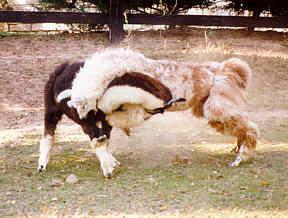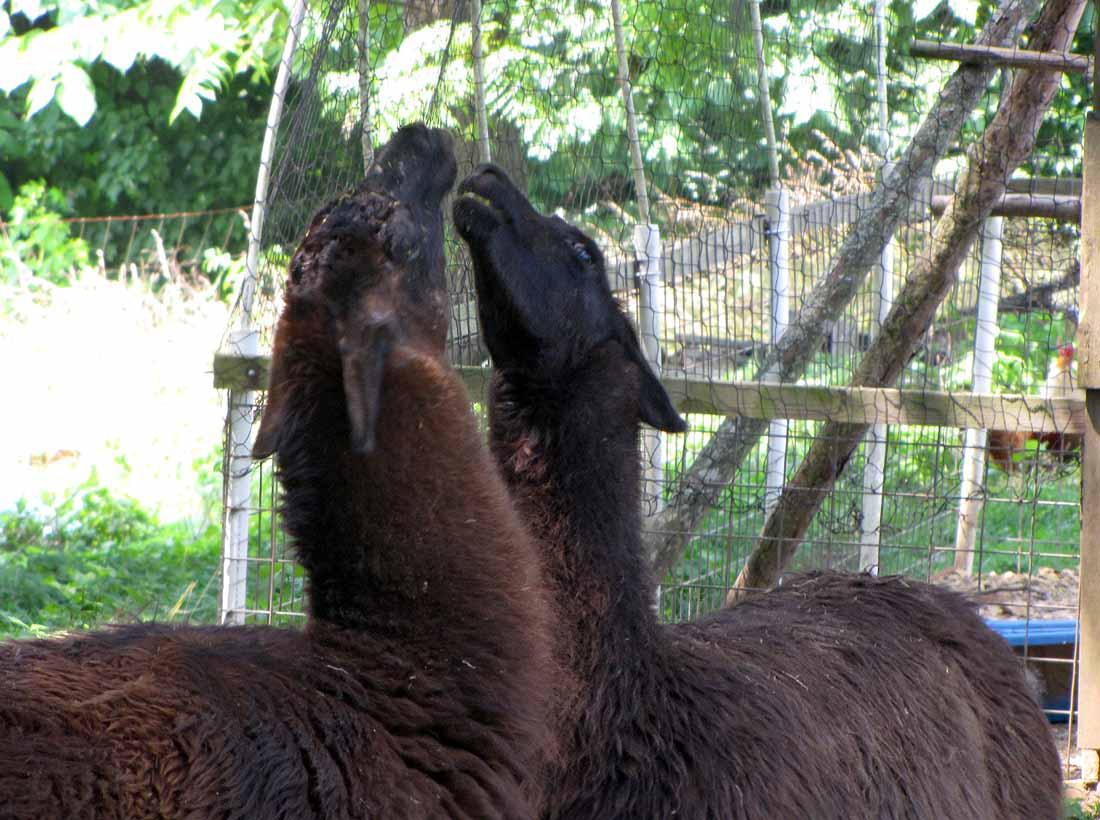The first image is the image on the left, the second image is the image on the right. For the images shown, is this caption "One of the images shows two animals fighting while standing on their hind legs." true? Answer yes or no. No. The first image is the image on the left, the second image is the image on the right. Given the left and right images, does the statement "In the right image, two dark solid-colored llamas are face-to-face, with their necks stretched." hold true? Answer yes or no. Yes. 